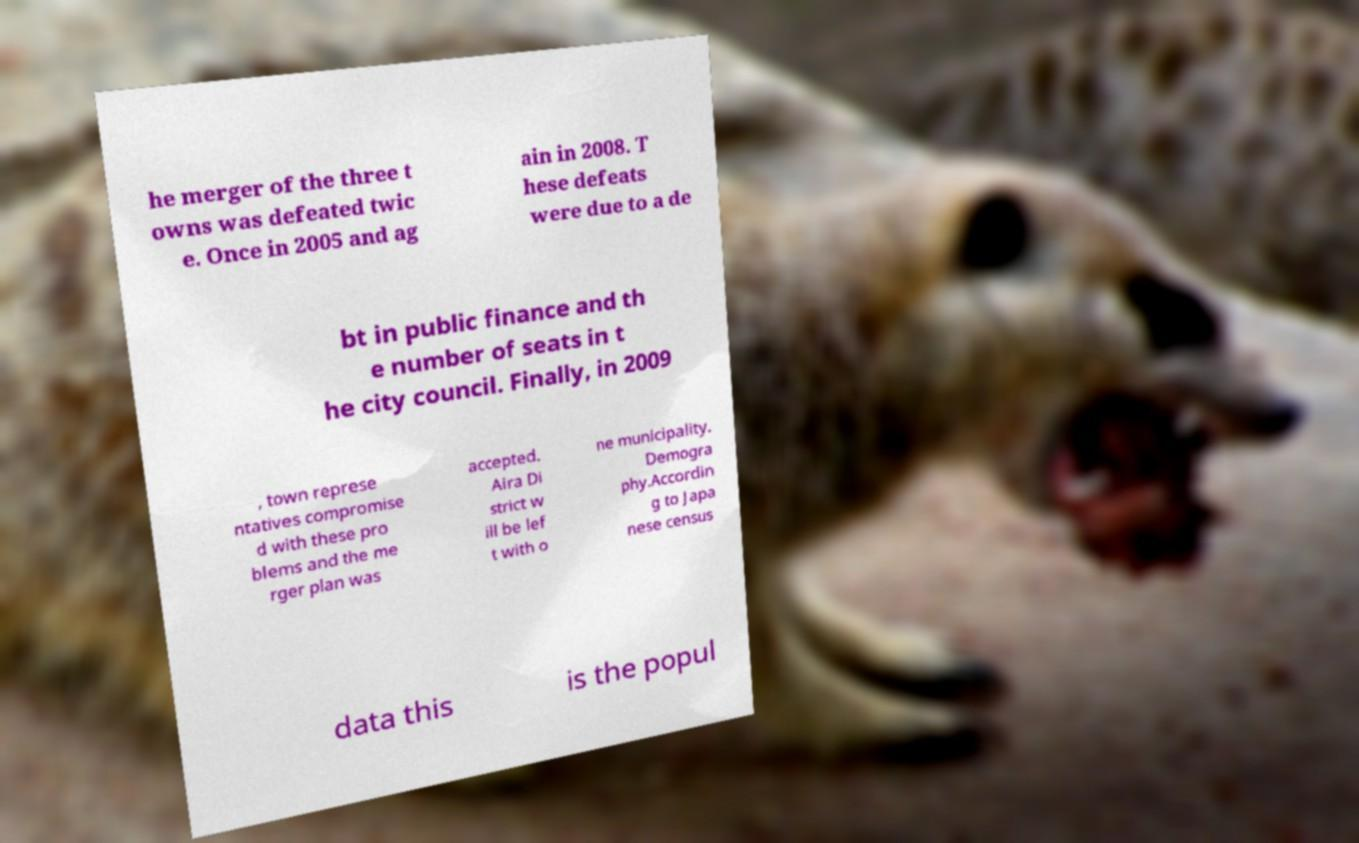Can you accurately transcribe the text from the provided image for me? he merger of the three t owns was defeated twic e. Once in 2005 and ag ain in 2008. T hese defeats were due to a de bt in public finance and th e number of seats in t he city council. Finally, in 2009 , town represe ntatives compromise d with these pro blems and the me rger plan was accepted. Aira Di strict w ill be lef t with o ne municipality. Demogra phy.Accordin g to Japa nese census data this is the popul 